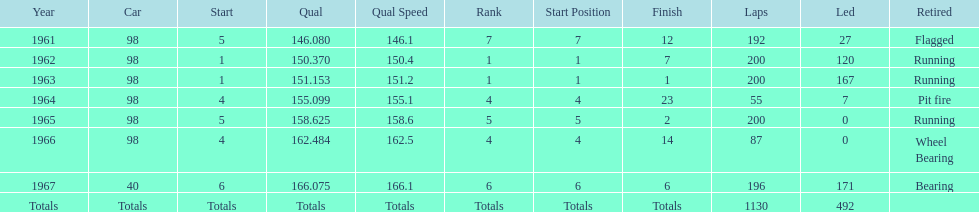How many total laps have been driven in the indy 500? 1130. 